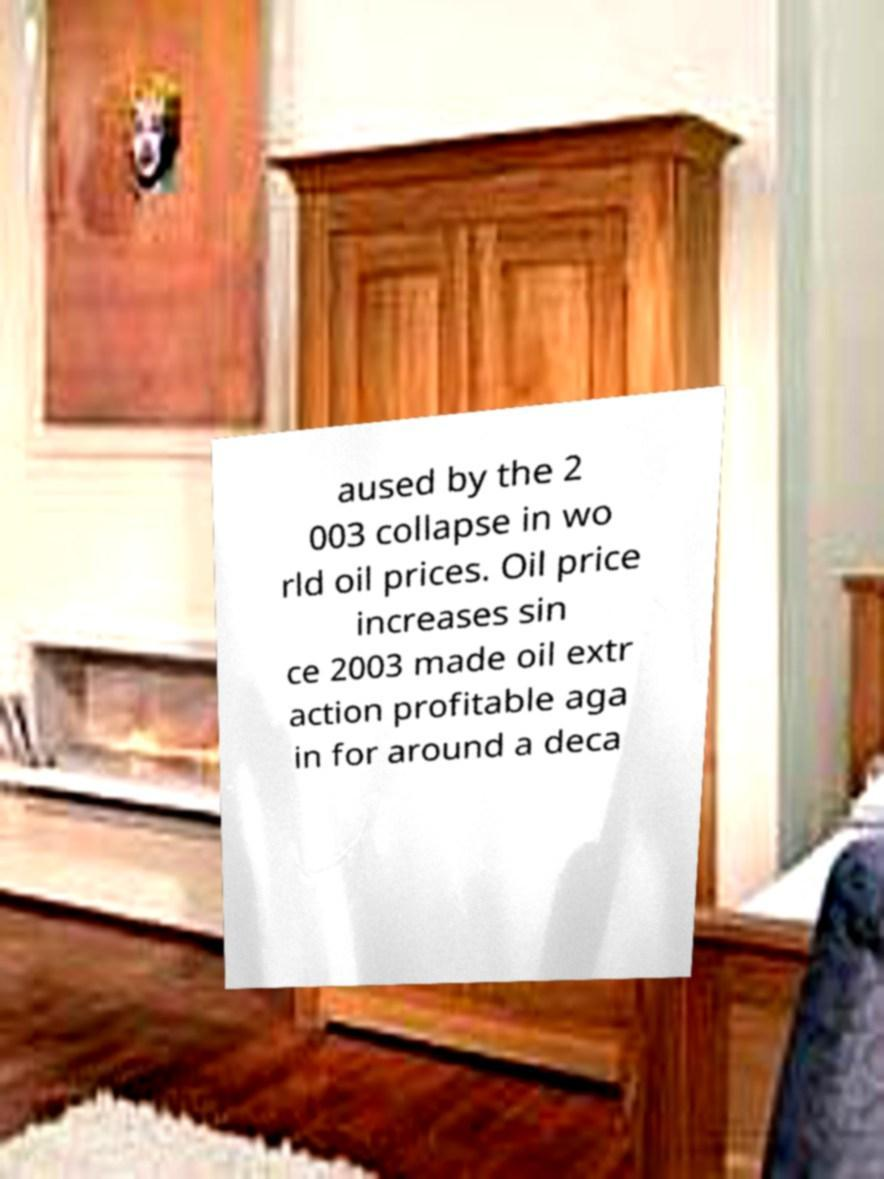I need the written content from this picture converted into text. Can you do that? aused by the 2 003 collapse in wo rld oil prices. Oil price increases sin ce 2003 made oil extr action profitable aga in for around a deca 